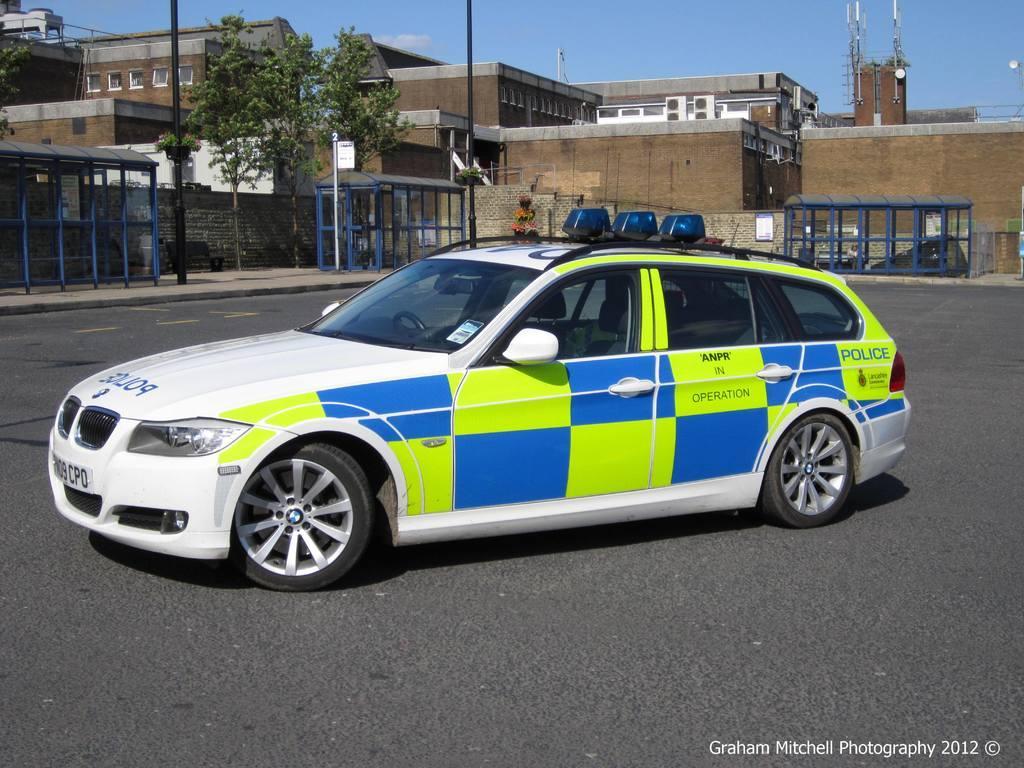Describe this image in one or two sentences. In this picture I can observe a car on the road. This car is in blue, green and white colors. In the background I can observe buildings, trees and a sky. 